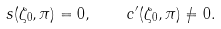<formula> <loc_0><loc_0><loc_500><loc_500>s ( \zeta _ { 0 } , \pi ) = 0 , \quad c ^ { \prime } ( \zeta _ { 0 } , \pi ) \neq 0 .</formula> 